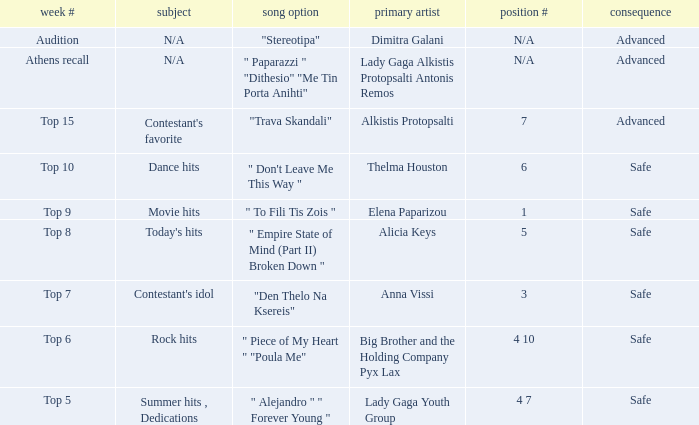When was the song "empire state of mind (part ii) broken down" featured as a choice in a week? Top 8. 